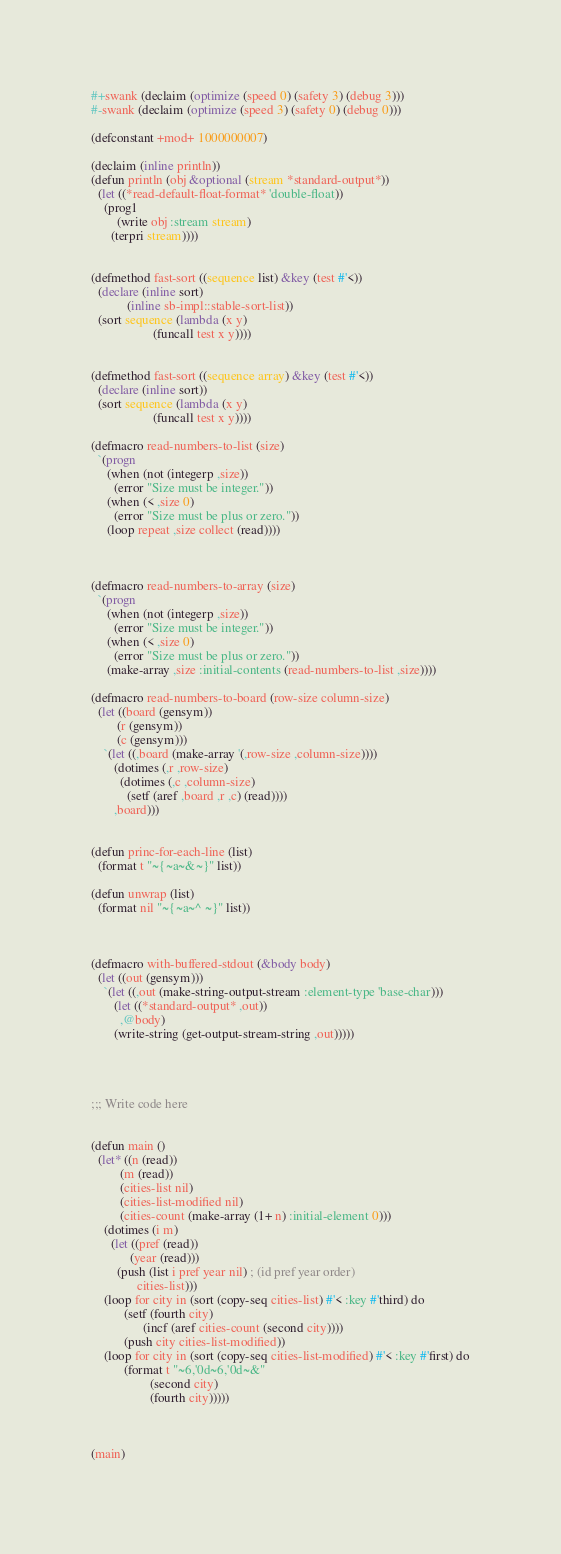<code> <loc_0><loc_0><loc_500><loc_500><_Lisp_>#+swank (declaim (optimize (speed 0) (safety 3) (debug 3)))
#-swank (declaim (optimize (speed 3) (safety 0) (debug 0)))

(defconstant +mod+ 1000000007)

(declaim (inline println))
(defun println (obj &optional (stream *standard-output*))
  (let ((*read-default-float-format* 'double-float))
    (prog1
        (write obj :stream stream)
      (terpri stream))))


(defmethod fast-sort ((sequence list) &key (test #'<))
  (declare (inline sort)
           (inline sb-impl::stable-sort-list))
  (sort sequence (lambda (x y)
                   (funcall test x y))))


(defmethod fast-sort ((sequence array) &key (test #'<))
  (declare (inline sort))
  (sort sequence (lambda (x y)
                   (funcall test x y))))

(defmacro read-numbers-to-list (size)
  `(progn
     (when (not (integerp ,size))
       (error "Size must be integer."))
     (when (< ,size 0)
       (error "Size must be plus or zero."))
     (loop repeat ,size collect (read))))



(defmacro read-numbers-to-array (size)
  `(progn
     (when (not (integerp ,size))
       (error "Size must be integer."))
     (when (< ,size 0)
       (error "Size must be plus or zero."))
     (make-array ,size :initial-contents (read-numbers-to-list ,size))))

(defmacro read-numbers-to-board (row-size column-size)
  (let ((board (gensym))
        (r (gensym))
        (c (gensym)))
    `(let ((,board (make-array '(,row-size ,column-size))))
       (dotimes (,r ,row-size)
         (dotimes (,c ,column-size)
           (setf (aref ,board ,r ,c) (read))))
       ,board)))


(defun princ-for-each-line (list)
  (format t "~{~a~&~}" list))

(defun unwrap (list)
  (format nil "~{~a~^ ~}" list))



(defmacro with-buffered-stdout (&body body)
  (let ((out (gensym)))
    `(let ((,out (make-string-output-stream :element-type 'base-char)))
       (let ((*standard-output* ,out))
         ,@body)
       (write-string (get-output-stream-string ,out)))))




;;; Write code here


(defun main ()
  (let* ((n (read))
         (m (read))
         (cities-list nil)
         (cities-list-modified nil)
         (cities-count (make-array (1+ n) :initial-element 0)))
    (dotimes (i m)
      (let ((pref (read))
            (year (read)))
        (push (list i pref year nil) ; (id pref year order)
              cities-list)))
    (loop for city in (sort (copy-seq cities-list) #'< :key #'third) do
          (setf (fourth city)
                (incf (aref cities-count (second city))))
          (push city cities-list-modified))
    (loop for city in (sort (copy-seq cities-list-modified) #'< :key #'first) do
          (format t "~6,'0d~6,'0d~&"
                  (second city)
                  (fourth city)))))



(main)
</code> 